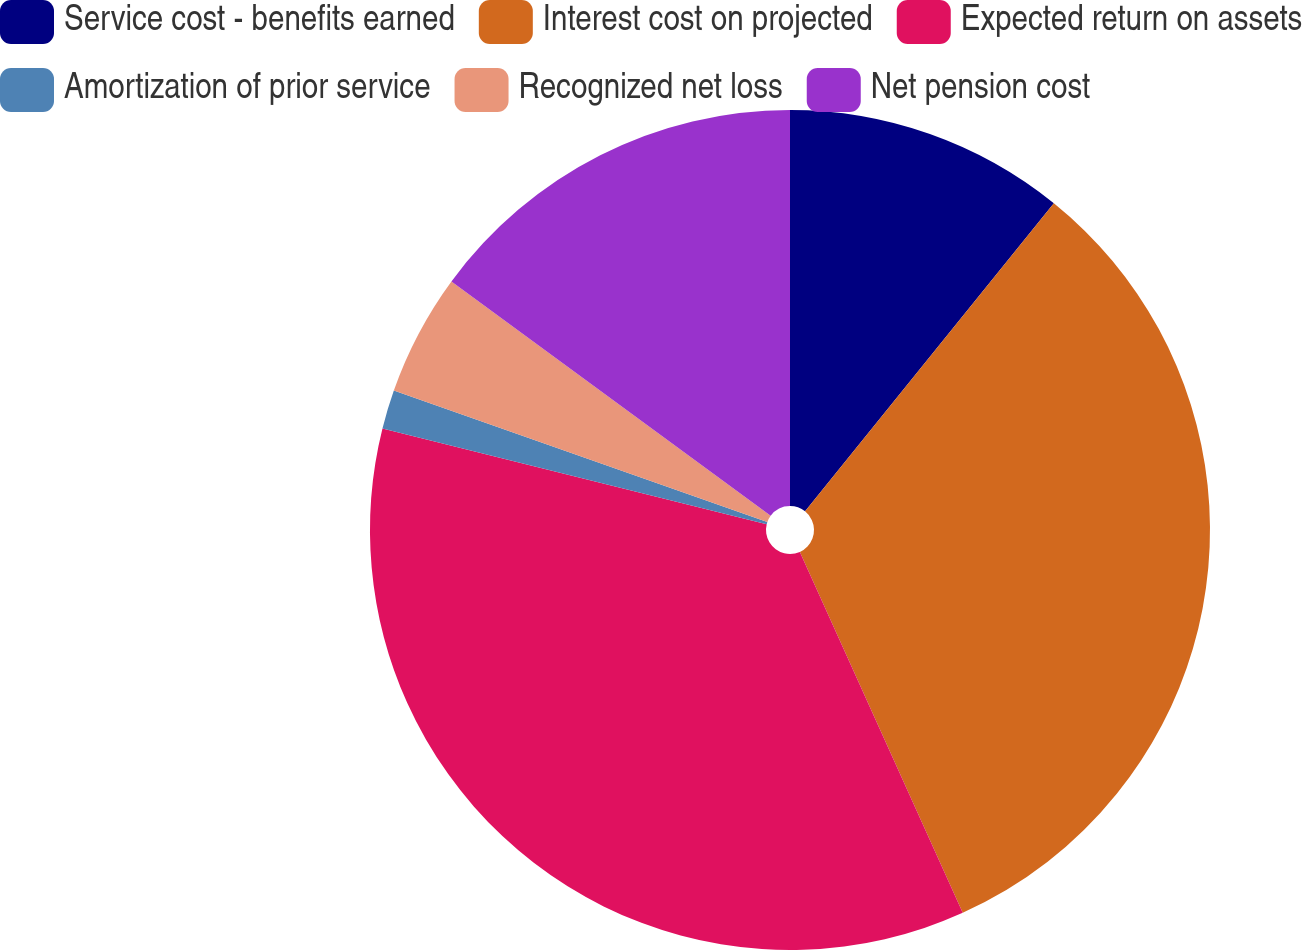<chart> <loc_0><loc_0><loc_500><loc_500><pie_chart><fcel>Service cost - benefits earned<fcel>Interest cost on projected<fcel>Expected return on assets<fcel>Amortization of prior service<fcel>Recognized net loss<fcel>Net pension cost<nl><fcel>10.81%<fcel>32.44%<fcel>35.63%<fcel>1.5%<fcel>4.69%<fcel>14.92%<nl></chart> 